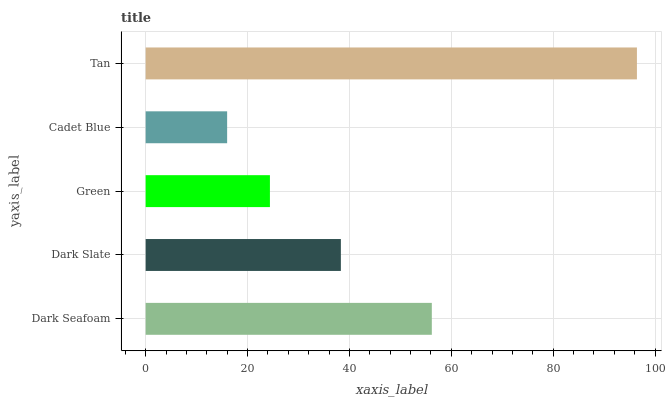Is Cadet Blue the minimum?
Answer yes or no. Yes. Is Tan the maximum?
Answer yes or no. Yes. Is Dark Slate the minimum?
Answer yes or no. No. Is Dark Slate the maximum?
Answer yes or no. No. Is Dark Seafoam greater than Dark Slate?
Answer yes or no. Yes. Is Dark Slate less than Dark Seafoam?
Answer yes or no. Yes. Is Dark Slate greater than Dark Seafoam?
Answer yes or no. No. Is Dark Seafoam less than Dark Slate?
Answer yes or no. No. Is Dark Slate the high median?
Answer yes or no. Yes. Is Dark Slate the low median?
Answer yes or no. Yes. Is Dark Seafoam the high median?
Answer yes or no. No. Is Cadet Blue the low median?
Answer yes or no. No. 